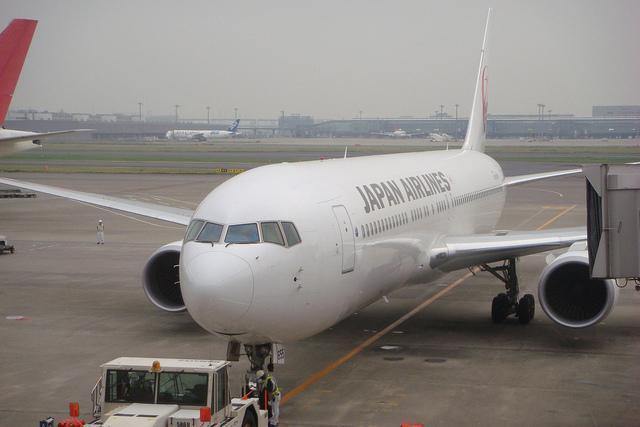What is the official language of this airline's country?
Answer the question by selecting the correct answer among the 4 following choices and explain your choice with a short sentence. The answer should be formatted with the following format: `Answer: choice
Rationale: rationale.`
Options: Japanese, chinese, korean, russian. Answer: japanese.
Rationale: The airplane is owned by japan airline and their official language is japanese. 